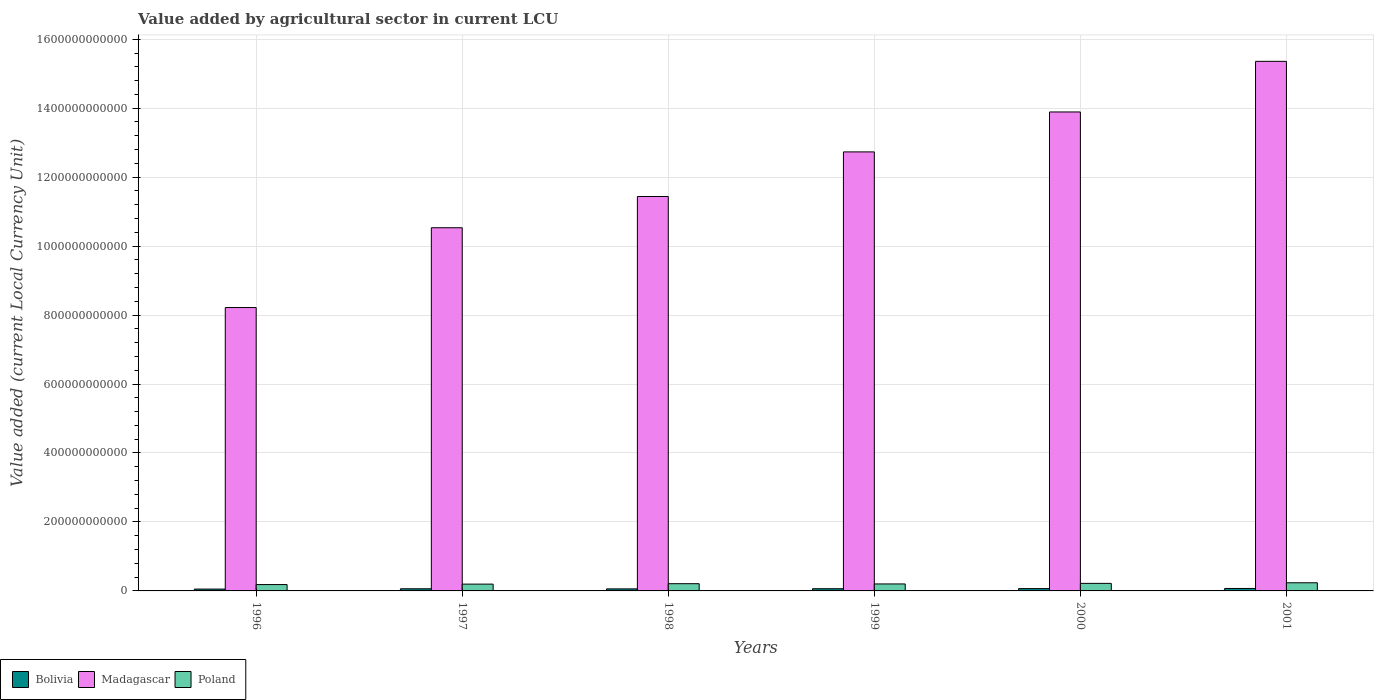Are the number of bars on each tick of the X-axis equal?
Provide a short and direct response. Yes. How many bars are there on the 4th tick from the left?
Ensure brevity in your answer.  3. How many bars are there on the 6th tick from the right?
Your response must be concise. 3. What is the value added by agricultural sector in Madagascar in 1998?
Your answer should be compact. 1.14e+12. Across all years, what is the maximum value added by agricultural sector in Poland?
Give a very brief answer. 2.36e+1. Across all years, what is the minimum value added by agricultural sector in Bolivia?
Your answer should be very brief. 5.32e+09. What is the total value added by agricultural sector in Madagascar in the graph?
Give a very brief answer. 7.22e+12. What is the difference between the value added by agricultural sector in Poland in 2000 and that in 2001?
Keep it short and to the point. -1.78e+09. What is the difference between the value added by agricultural sector in Poland in 2000 and the value added by agricultural sector in Bolivia in 1998?
Your response must be concise. 1.59e+1. What is the average value added by agricultural sector in Poland per year?
Give a very brief answer. 2.08e+1. In the year 1997, what is the difference between the value added by agricultural sector in Bolivia and value added by agricultural sector in Poland?
Your response must be concise. -1.35e+1. What is the ratio of the value added by agricultural sector in Bolivia in 1996 to that in 2001?
Give a very brief answer. 0.75. Is the value added by agricultural sector in Poland in 1998 less than that in 1999?
Your answer should be very brief. No. Is the difference between the value added by agricultural sector in Bolivia in 1998 and 1999 greater than the difference between the value added by agricultural sector in Poland in 1998 and 1999?
Your answer should be very brief. No. What is the difference between the highest and the second highest value added by agricultural sector in Bolivia?
Provide a succinct answer. 3.97e+08. What is the difference between the highest and the lowest value added by agricultural sector in Bolivia?
Offer a very short reply. 1.81e+09. Is the sum of the value added by agricultural sector in Poland in 1997 and 1999 greater than the maximum value added by agricultural sector in Bolivia across all years?
Your answer should be compact. Yes. What does the 3rd bar from the left in 1997 represents?
Provide a short and direct response. Poland. Are all the bars in the graph horizontal?
Make the answer very short. No. How many years are there in the graph?
Provide a succinct answer. 6. What is the difference between two consecutive major ticks on the Y-axis?
Keep it short and to the point. 2.00e+11. Are the values on the major ticks of Y-axis written in scientific E-notation?
Your answer should be compact. No. Where does the legend appear in the graph?
Provide a short and direct response. Bottom left. What is the title of the graph?
Offer a very short reply. Value added by agricultural sector in current LCU. Does "Trinidad and Tobago" appear as one of the legend labels in the graph?
Your response must be concise. No. What is the label or title of the X-axis?
Offer a terse response. Years. What is the label or title of the Y-axis?
Your response must be concise. Value added (current Local Currency Unit). What is the Value added (current Local Currency Unit) of Bolivia in 1996?
Ensure brevity in your answer.  5.32e+09. What is the Value added (current Local Currency Unit) in Madagascar in 1996?
Offer a terse response. 8.22e+11. What is the Value added (current Local Currency Unit) in Poland in 1996?
Your answer should be compact. 1.84e+1. What is the Value added (current Local Currency Unit) in Bolivia in 1997?
Offer a terse response. 6.21e+09. What is the Value added (current Local Currency Unit) of Madagascar in 1997?
Provide a short and direct response. 1.05e+12. What is the Value added (current Local Currency Unit) in Poland in 1997?
Provide a succinct answer. 1.97e+1. What is the Value added (current Local Currency Unit) in Bolivia in 1998?
Offer a terse response. 5.91e+09. What is the Value added (current Local Currency Unit) of Madagascar in 1998?
Your response must be concise. 1.14e+12. What is the Value added (current Local Currency Unit) of Poland in 1998?
Provide a succinct answer. 2.09e+1. What is the Value added (current Local Currency Unit) of Bolivia in 1999?
Provide a succinct answer. 6.38e+09. What is the Value added (current Local Currency Unit) of Madagascar in 1999?
Keep it short and to the point. 1.27e+12. What is the Value added (current Local Currency Unit) of Poland in 1999?
Offer a very short reply. 2.02e+1. What is the Value added (current Local Currency Unit) of Bolivia in 2000?
Offer a very short reply. 6.73e+09. What is the Value added (current Local Currency Unit) in Madagascar in 2000?
Provide a succinct answer. 1.39e+12. What is the Value added (current Local Currency Unit) of Poland in 2000?
Offer a very short reply. 2.18e+1. What is the Value added (current Local Currency Unit) of Bolivia in 2001?
Offer a terse response. 7.13e+09. What is the Value added (current Local Currency Unit) of Madagascar in 2001?
Provide a short and direct response. 1.54e+12. What is the Value added (current Local Currency Unit) in Poland in 2001?
Ensure brevity in your answer.  2.36e+1. Across all years, what is the maximum Value added (current Local Currency Unit) in Bolivia?
Offer a terse response. 7.13e+09. Across all years, what is the maximum Value added (current Local Currency Unit) in Madagascar?
Make the answer very short. 1.54e+12. Across all years, what is the maximum Value added (current Local Currency Unit) in Poland?
Your answer should be compact. 2.36e+1. Across all years, what is the minimum Value added (current Local Currency Unit) in Bolivia?
Ensure brevity in your answer.  5.32e+09. Across all years, what is the minimum Value added (current Local Currency Unit) of Madagascar?
Your answer should be compact. 8.22e+11. Across all years, what is the minimum Value added (current Local Currency Unit) of Poland?
Your answer should be compact. 1.84e+1. What is the total Value added (current Local Currency Unit) of Bolivia in the graph?
Keep it short and to the point. 3.77e+1. What is the total Value added (current Local Currency Unit) of Madagascar in the graph?
Your answer should be very brief. 7.22e+12. What is the total Value added (current Local Currency Unit) of Poland in the graph?
Your answer should be very brief. 1.25e+11. What is the difference between the Value added (current Local Currency Unit) in Bolivia in 1996 and that in 1997?
Provide a short and direct response. -8.88e+08. What is the difference between the Value added (current Local Currency Unit) of Madagascar in 1996 and that in 1997?
Offer a very short reply. -2.31e+11. What is the difference between the Value added (current Local Currency Unit) of Poland in 1996 and that in 1997?
Your answer should be very brief. -1.31e+09. What is the difference between the Value added (current Local Currency Unit) of Bolivia in 1996 and that in 1998?
Offer a very short reply. -5.87e+08. What is the difference between the Value added (current Local Currency Unit) of Madagascar in 1996 and that in 1998?
Offer a terse response. -3.22e+11. What is the difference between the Value added (current Local Currency Unit) in Poland in 1996 and that in 1998?
Offer a very short reply. -2.53e+09. What is the difference between the Value added (current Local Currency Unit) in Bolivia in 1996 and that in 1999?
Your answer should be very brief. -1.06e+09. What is the difference between the Value added (current Local Currency Unit) of Madagascar in 1996 and that in 1999?
Keep it short and to the point. -4.51e+11. What is the difference between the Value added (current Local Currency Unit) in Poland in 1996 and that in 1999?
Provide a short and direct response. -1.80e+09. What is the difference between the Value added (current Local Currency Unit) in Bolivia in 1996 and that in 2000?
Your answer should be very brief. -1.41e+09. What is the difference between the Value added (current Local Currency Unit) of Madagascar in 1996 and that in 2000?
Your response must be concise. -5.67e+11. What is the difference between the Value added (current Local Currency Unit) of Poland in 1996 and that in 2000?
Ensure brevity in your answer.  -3.42e+09. What is the difference between the Value added (current Local Currency Unit) of Bolivia in 1996 and that in 2001?
Offer a terse response. -1.81e+09. What is the difference between the Value added (current Local Currency Unit) in Madagascar in 1996 and that in 2001?
Provide a short and direct response. -7.14e+11. What is the difference between the Value added (current Local Currency Unit) in Poland in 1996 and that in 2001?
Provide a succinct answer. -5.20e+09. What is the difference between the Value added (current Local Currency Unit) in Bolivia in 1997 and that in 1998?
Ensure brevity in your answer.  3.01e+08. What is the difference between the Value added (current Local Currency Unit) in Madagascar in 1997 and that in 1998?
Your answer should be compact. -9.06e+1. What is the difference between the Value added (current Local Currency Unit) of Poland in 1997 and that in 1998?
Give a very brief answer. -1.22e+09. What is the difference between the Value added (current Local Currency Unit) in Bolivia in 1997 and that in 1999?
Keep it short and to the point. -1.72e+08. What is the difference between the Value added (current Local Currency Unit) in Madagascar in 1997 and that in 1999?
Make the answer very short. -2.20e+11. What is the difference between the Value added (current Local Currency Unit) in Poland in 1997 and that in 1999?
Your answer should be very brief. -4.92e+08. What is the difference between the Value added (current Local Currency Unit) of Bolivia in 1997 and that in 2000?
Your answer should be very brief. -5.20e+08. What is the difference between the Value added (current Local Currency Unit) in Madagascar in 1997 and that in 2000?
Make the answer very short. -3.36e+11. What is the difference between the Value added (current Local Currency Unit) in Poland in 1997 and that in 2000?
Keep it short and to the point. -2.11e+09. What is the difference between the Value added (current Local Currency Unit) in Bolivia in 1997 and that in 2001?
Ensure brevity in your answer.  -9.18e+08. What is the difference between the Value added (current Local Currency Unit) of Madagascar in 1997 and that in 2001?
Offer a very short reply. -4.83e+11. What is the difference between the Value added (current Local Currency Unit) of Poland in 1997 and that in 2001?
Offer a very short reply. -3.89e+09. What is the difference between the Value added (current Local Currency Unit) in Bolivia in 1998 and that in 1999?
Offer a very short reply. -4.73e+08. What is the difference between the Value added (current Local Currency Unit) in Madagascar in 1998 and that in 1999?
Ensure brevity in your answer.  -1.29e+11. What is the difference between the Value added (current Local Currency Unit) in Poland in 1998 and that in 1999?
Give a very brief answer. 7.26e+08. What is the difference between the Value added (current Local Currency Unit) in Bolivia in 1998 and that in 2000?
Provide a succinct answer. -8.21e+08. What is the difference between the Value added (current Local Currency Unit) of Madagascar in 1998 and that in 2000?
Your response must be concise. -2.45e+11. What is the difference between the Value added (current Local Currency Unit) of Poland in 1998 and that in 2000?
Your response must be concise. -8.96e+08. What is the difference between the Value added (current Local Currency Unit) in Bolivia in 1998 and that in 2001?
Ensure brevity in your answer.  -1.22e+09. What is the difference between the Value added (current Local Currency Unit) in Madagascar in 1998 and that in 2001?
Offer a very short reply. -3.92e+11. What is the difference between the Value added (current Local Currency Unit) of Poland in 1998 and that in 2001?
Ensure brevity in your answer.  -2.68e+09. What is the difference between the Value added (current Local Currency Unit) of Bolivia in 1999 and that in 2000?
Offer a very short reply. -3.48e+08. What is the difference between the Value added (current Local Currency Unit) in Madagascar in 1999 and that in 2000?
Offer a terse response. -1.16e+11. What is the difference between the Value added (current Local Currency Unit) of Poland in 1999 and that in 2000?
Provide a succinct answer. -1.62e+09. What is the difference between the Value added (current Local Currency Unit) in Bolivia in 1999 and that in 2001?
Your response must be concise. -7.46e+08. What is the difference between the Value added (current Local Currency Unit) of Madagascar in 1999 and that in 2001?
Your answer should be compact. -2.63e+11. What is the difference between the Value added (current Local Currency Unit) of Poland in 1999 and that in 2001?
Your response must be concise. -3.40e+09. What is the difference between the Value added (current Local Currency Unit) of Bolivia in 2000 and that in 2001?
Offer a very short reply. -3.97e+08. What is the difference between the Value added (current Local Currency Unit) of Madagascar in 2000 and that in 2001?
Ensure brevity in your answer.  -1.47e+11. What is the difference between the Value added (current Local Currency Unit) in Poland in 2000 and that in 2001?
Offer a terse response. -1.78e+09. What is the difference between the Value added (current Local Currency Unit) in Bolivia in 1996 and the Value added (current Local Currency Unit) in Madagascar in 1997?
Ensure brevity in your answer.  -1.05e+12. What is the difference between the Value added (current Local Currency Unit) in Bolivia in 1996 and the Value added (current Local Currency Unit) in Poland in 1997?
Provide a short and direct response. -1.44e+1. What is the difference between the Value added (current Local Currency Unit) in Madagascar in 1996 and the Value added (current Local Currency Unit) in Poland in 1997?
Your answer should be very brief. 8.02e+11. What is the difference between the Value added (current Local Currency Unit) in Bolivia in 1996 and the Value added (current Local Currency Unit) in Madagascar in 1998?
Provide a succinct answer. -1.14e+12. What is the difference between the Value added (current Local Currency Unit) in Bolivia in 1996 and the Value added (current Local Currency Unit) in Poland in 1998?
Ensure brevity in your answer.  -1.56e+1. What is the difference between the Value added (current Local Currency Unit) in Madagascar in 1996 and the Value added (current Local Currency Unit) in Poland in 1998?
Offer a terse response. 8.01e+11. What is the difference between the Value added (current Local Currency Unit) in Bolivia in 1996 and the Value added (current Local Currency Unit) in Madagascar in 1999?
Your answer should be very brief. -1.27e+12. What is the difference between the Value added (current Local Currency Unit) in Bolivia in 1996 and the Value added (current Local Currency Unit) in Poland in 1999?
Give a very brief answer. -1.49e+1. What is the difference between the Value added (current Local Currency Unit) in Madagascar in 1996 and the Value added (current Local Currency Unit) in Poland in 1999?
Ensure brevity in your answer.  8.02e+11. What is the difference between the Value added (current Local Currency Unit) in Bolivia in 1996 and the Value added (current Local Currency Unit) in Madagascar in 2000?
Offer a very short reply. -1.38e+12. What is the difference between the Value added (current Local Currency Unit) in Bolivia in 1996 and the Value added (current Local Currency Unit) in Poland in 2000?
Your response must be concise. -1.65e+1. What is the difference between the Value added (current Local Currency Unit) of Madagascar in 1996 and the Value added (current Local Currency Unit) of Poland in 2000?
Offer a very short reply. 8.00e+11. What is the difference between the Value added (current Local Currency Unit) of Bolivia in 1996 and the Value added (current Local Currency Unit) of Madagascar in 2001?
Your answer should be very brief. -1.53e+12. What is the difference between the Value added (current Local Currency Unit) of Bolivia in 1996 and the Value added (current Local Currency Unit) of Poland in 2001?
Provide a succinct answer. -1.83e+1. What is the difference between the Value added (current Local Currency Unit) of Madagascar in 1996 and the Value added (current Local Currency Unit) of Poland in 2001?
Your response must be concise. 7.98e+11. What is the difference between the Value added (current Local Currency Unit) in Bolivia in 1997 and the Value added (current Local Currency Unit) in Madagascar in 1998?
Ensure brevity in your answer.  -1.14e+12. What is the difference between the Value added (current Local Currency Unit) in Bolivia in 1997 and the Value added (current Local Currency Unit) in Poland in 1998?
Your answer should be very brief. -1.47e+1. What is the difference between the Value added (current Local Currency Unit) of Madagascar in 1997 and the Value added (current Local Currency Unit) of Poland in 1998?
Offer a terse response. 1.03e+12. What is the difference between the Value added (current Local Currency Unit) in Bolivia in 1997 and the Value added (current Local Currency Unit) in Madagascar in 1999?
Offer a very short reply. -1.27e+12. What is the difference between the Value added (current Local Currency Unit) of Bolivia in 1997 and the Value added (current Local Currency Unit) of Poland in 1999?
Give a very brief answer. -1.40e+1. What is the difference between the Value added (current Local Currency Unit) in Madagascar in 1997 and the Value added (current Local Currency Unit) in Poland in 1999?
Your response must be concise. 1.03e+12. What is the difference between the Value added (current Local Currency Unit) in Bolivia in 1997 and the Value added (current Local Currency Unit) in Madagascar in 2000?
Your response must be concise. -1.38e+12. What is the difference between the Value added (current Local Currency Unit) of Bolivia in 1997 and the Value added (current Local Currency Unit) of Poland in 2000?
Your response must be concise. -1.56e+1. What is the difference between the Value added (current Local Currency Unit) in Madagascar in 1997 and the Value added (current Local Currency Unit) in Poland in 2000?
Ensure brevity in your answer.  1.03e+12. What is the difference between the Value added (current Local Currency Unit) of Bolivia in 1997 and the Value added (current Local Currency Unit) of Madagascar in 2001?
Provide a short and direct response. -1.53e+12. What is the difference between the Value added (current Local Currency Unit) in Bolivia in 1997 and the Value added (current Local Currency Unit) in Poland in 2001?
Keep it short and to the point. -1.74e+1. What is the difference between the Value added (current Local Currency Unit) of Madagascar in 1997 and the Value added (current Local Currency Unit) of Poland in 2001?
Your answer should be very brief. 1.03e+12. What is the difference between the Value added (current Local Currency Unit) of Bolivia in 1998 and the Value added (current Local Currency Unit) of Madagascar in 1999?
Provide a succinct answer. -1.27e+12. What is the difference between the Value added (current Local Currency Unit) of Bolivia in 1998 and the Value added (current Local Currency Unit) of Poland in 1999?
Your answer should be very brief. -1.43e+1. What is the difference between the Value added (current Local Currency Unit) in Madagascar in 1998 and the Value added (current Local Currency Unit) in Poland in 1999?
Offer a very short reply. 1.12e+12. What is the difference between the Value added (current Local Currency Unit) of Bolivia in 1998 and the Value added (current Local Currency Unit) of Madagascar in 2000?
Provide a succinct answer. -1.38e+12. What is the difference between the Value added (current Local Currency Unit) of Bolivia in 1998 and the Value added (current Local Currency Unit) of Poland in 2000?
Offer a very short reply. -1.59e+1. What is the difference between the Value added (current Local Currency Unit) of Madagascar in 1998 and the Value added (current Local Currency Unit) of Poland in 2000?
Your answer should be very brief. 1.12e+12. What is the difference between the Value added (current Local Currency Unit) of Bolivia in 1998 and the Value added (current Local Currency Unit) of Madagascar in 2001?
Offer a very short reply. -1.53e+12. What is the difference between the Value added (current Local Currency Unit) of Bolivia in 1998 and the Value added (current Local Currency Unit) of Poland in 2001?
Ensure brevity in your answer.  -1.77e+1. What is the difference between the Value added (current Local Currency Unit) in Madagascar in 1998 and the Value added (current Local Currency Unit) in Poland in 2001?
Keep it short and to the point. 1.12e+12. What is the difference between the Value added (current Local Currency Unit) in Bolivia in 1999 and the Value added (current Local Currency Unit) in Madagascar in 2000?
Make the answer very short. -1.38e+12. What is the difference between the Value added (current Local Currency Unit) in Bolivia in 1999 and the Value added (current Local Currency Unit) in Poland in 2000?
Keep it short and to the point. -1.55e+1. What is the difference between the Value added (current Local Currency Unit) of Madagascar in 1999 and the Value added (current Local Currency Unit) of Poland in 2000?
Offer a terse response. 1.25e+12. What is the difference between the Value added (current Local Currency Unit) of Bolivia in 1999 and the Value added (current Local Currency Unit) of Madagascar in 2001?
Offer a terse response. -1.53e+12. What is the difference between the Value added (current Local Currency Unit) in Bolivia in 1999 and the Value added (current Local Currency Unit) in Poland in 2001?
Make the answer very short. -1.72e+1. What is the difference between the Value added (current Local Currency Unit) in Madagascar in 1999 and the Value added (current Local Currency Unit) in Poland in 2001?
Make the answer very short. 1.25e+12. What is the difference between the Value added (current Local Currency Unit) of Bolivia in 2000 and the Value added (current Local Currency Unit) of Madagascar in 2001?
Ensure brevity in your answer.  -1.53e+12. What is the difference between the Value added (current Local Currency Unit) in Bolivia in 2000 and the Value added (current Local Currency Unit) in Poland in 2001?
Offer a very short reply. -1.69e+1. What is the difference between the Value added (current Local Currency Unit) in Madagascar in 2000 and the Value added (current Local Currency Unit) in Poland in 2001?
Your answer should be compact. 1.37e+12. What is the average Value added (current Local Currency Unit) of Bolivia per year?
Provide a succinct answer. 6.28e+09. What is the average Value added (current Local Currency Unit) in Madagascar per year?
Offer a terse response. 1.20e+12. What is the average Value added (current Local Currency Unit) in Poland per year?
Offer a terse response. 2.08e+1. In the year 1996, what is the difference between the Value added (current Local Currency Unit) in Bolivia and Value added (current Local Currency Unit) in Madagascar?
Keep it short and to the point. -8.17e+11. In the year 1996, what is the difference between the Value added (current Local Currency Unit) in Bolivia and Value added (current Local Currency Unit) in Poland?
Your answer should be very brief. -1.31e+1. In the year 1996, what is the difference between the Value added (current Local Currency Unit) in Madagascar and Value added (current Local Currency Unit) in Poland?
Your answer should be very brief. 8.03e+11. In the year 1997, what is the difference between the Value added (current Local Currency Unit) of Bolivia and Value added (current Local Currency Unit) of Madagascar?
Make the answer very short. -1.05e+12. In the year 1997, what is the difference between the Value added (current Local Currency Unit) of Bolivia and Value added (current Local Currency Unit) of Poland?
Your answer should be compact. -1.35e+1. In the year 1997, what is the difference between the Value added (current Local Currency Unit) of Madagascar and Value added (current Local Currency Unit) of Poland?
Your response must be concise. 1.03e+12. In the year 1998, what is the difference between the Value added (current Local Currency Unit) of Bolivia and Value added (current Local Currency Unit) of Madagascar?
Your answer should be compact. -1.14e+12. In the year 1998, what is the difference between the Value added (current Local Currency Unit) of Bolivia and Value added (current Local Currency Unit) of Poland?
Your answer should be very brief. -1.50e+1. In the year 1998, what is the difference between the Value added (current Local Currency Unit) of Madagascar and Value added (current Local Currency Unit) of Poland?
Offer a very short reply. 1.12e+12. In the year 1999, what is the difference between the Value added (current Local Currency Unit) in Bolivia and Value added (current Local Currency Unit) in Madagascar?
Provide a short and direct response. -1.27e+12. In the year 1999, what is the difference between the Value added (current Local Currency Unit) in Bolivia and Value added (current Local Currency Unit) in Poland?
Make the answer very short. -1.38e+1. In the year 1999, what is the difference between the Value added (current Local Currency Unit) of Madagascar and Value added (current Local Currency Unit) of Poland?
Make the answer very short. 1.25e+12. In the year 2000, what is the difference between the Value added (current Local Currency Unit) of Bolivia and Value added (current Local Currency Unit) of Madagascar?
Your answer should be compact. -1.38e+12. In the year 2000, what is the difference between the Value added (current Local Currency Unit) in Bolivia and Value added (current Local Currency Unit) in Poland?
Offer a very short reply. -1.51e+1. In the year 2000, what is the difference between the Value added (current Local Currency Unit) in Madagascar and Value added (current Local Currency Unit) in Poland?
Your answer should be very brief. 1.37e+12. In the year 2001, what is the difference between the Value added (current Local Currency Unit) of Bolivia and Value added (current Local Currency Unit) of Madagascar?
Provide a short and direct response. -1.53e+12. In the year 2001, what is the difference between the Value added (current Local Currency Unit) in Bolivia and Value added (current Local Currency Unit) in Poland?
Make the answer very short. -1.65e+1. In the year 2001, what is the difference between the Value added (current Local Currency Unit) of Madagascar and Value added (current Local Currency Unit) of Poland?
Provide a short and direct response. 1.51e+12. What is the ratio of the Value added (current Local Currency Unit) of Bolivia in 1996 to that in 1997?
Provide a short and direct response. 0.86. What is the ratio of the Value added (current Local Currency Unit) in Madagascar in 1996 to that in 1997?
Make the answer very short. 0.78. What is the ratio of the Value added (current Local Currency Unit) of Poland in 1996 to that in 1997?
Your answer should be very brief. 0.93. What is the ratio of the Value added (current Local Currency Unit) in Bolivia in 1996 to that in 1998?
Ensure brevity in your answer.  0.9. What is the ratio of the Value added (current Local Currency Unit) of Madagascar in 1996 to that in 1998?
Provide a succinct answer. 0.72. What is the ratio of the Value added (current Local Currency Unit) of Poland in 1996 to that in 1998?
Your answer should be very brief. 0.88. What is the ratio of the Value added (current Local Currency Unit) in Bolivia in 1996 to that in 1999?
Provide a short and direct response. 0.83. What is the ratio of the Value added (current Local Currency Unit) of Madagascar in 1996 to that in 1999?
Keep it short and to the point. 0.65. What is the ratio of the Value added (current Local Currency Unit) in Poland in 1996 to that in 1999?
Your answer should be very brief. 0.91. What is the ratio of the Value added (current Local Currency Unit) of Bolivia in 1996 to that in 2000?
Give a very brief answer. 0.79. What is the ratio of the Value added (current Local Currency Unit) in Madagascar in 1996 to that in 2000?
Offer a very short reply. 0.59. What is the ratio of the Value added (current Local Currency Unit) of Poland in 1996 to that in 2000?
Keep it short and to the point. 0.84. What is the ratio of the Value added (current Local Currency Unit) of Bolivia in 1996 to that in 2001?
Ensure brevity in your answer.  0.75. What is the ratio of the Value added (current Local Currency Unit) in Madagascar in 1996 to that in 2001?
Provide a short and direct response. 0.54. What is the ratio of the Value added (current Local Currency Unit) of Poland in 1996 to that in 2001?
Give a very brief answer. 0.78. What is the ratio of the Value added (current Local Currency Unit) of Bolivia in 1997 to that in 1998?
Offer a terse response. 1.05. What is the ratio of the Value added (current Local Currency Unit) of Madagascar in 1997 to that in 1998?
Keep it short and to the point. 0.92. What is the ratio of the Value added (current Local Currency Unit) of Poland in 1997 to that in 1998?
Your answer should be compact. 0.94. What is the ratio of the Value added (current Local Currency Unit) in Bolivia in 1997 to that in 1999?
Keep it short and to the point. 0.97. What is the ratio of the Value added (current Local Currency Unit) of Madagascar in 1997 to that in 1999?
Ensure brevity in your answer.  0.83. What is the ratio of the Value added (current Local Currency Unit) of Poland in 1997 to that in 1999?
Your answer should be very brief. 0.98. What is the ratio of the Value added (current Local Currency Unit) in Bolivia in 1997 to that in 2000?
Your answer should be compact. 0.92. What is the ratio of the Value added (current Local Currency Unit) in Madagascar in 1997 to that in 2000?
Your answer should be compact. 0.76. What is the ratio of the Value added (current Local Currency Unit) in Poland in 1997 to that in 2000?
Provide a succinct answer. 0.9. What is the ratio of the Value added (current Local Currency Unit) in Bolivia in 1997 to that in 2001?
Your answer should be very brief. 0.87. What is the ratio of the Value added (current Local Currency Unit) in Madagascar in 1997 to that in 2001?
Keep it short and to the point. 0.69. What is the ratio of the Value added (current Local Currency Unit) in Poland in 1997 to that in 2001?
Keep it short and to the point. 0.84. What is the ratio of the Value added (current Local Currency Unit) in Bolivia in 1998 to that in 1999?
Ensure brevity in your answer.  0.93. What is the ratio of the Value added (current Local Currency Unit) in Madagascar in 1998 to that in 1999?
Provide a succinct answer. 0.9. What is the ratio of the Value added (current Local Currency Unit) of Poland in 1998 to that in 1999?
Offer a very short reply. 1.04. What is the ratio of the Value added (current Local Currency Unit) in Bolivia in 1998 to that in 2000?
Your answer should be very brief. 0.88. What is the ratio of the Value added (current Local Currency Unit) in Madagascar in 1998 to that in 2000?
Give a very brief answer. 0.82. What is the ratio of the Value added (current Local Currency Unit) of Poland in 1998 to that in 2000?
Your answer should be compact. 0.96. What is the ratio of the Value added (current Local Currency Unit) in Bolivia in 1998 to that in 2001?
Keep it short and to the point. 0.83. What is the ratio of the Value added (current Local Currency Unit) in Madagascar in 1998 to that in 2001?
Your response must be concise. 0.74. What is the ratio of the Value added (current Local Currency Unit) in Poland in 1998 to that in 2001?
Your answer should be very brief. 0.89. What is the ratio of the Value added (current Local Currency Unit) of Bolivia in 1999 to that in 2000?
Give a very brief answer. 0.95. What is the ratio of the Value added (current Local Currency Unit) of Madagascar in 1999 to that in 2000?
Give a very brief answer. 0.92. What is the ratio of the Value added (current Local Currency Unit) of Poland in 1999 to that in 2000?
Your answer should be compact. 0.93. What is the ratio of the Value added (current Local Currency Unit) in Bolivia in 1999 to that in 2001?
Your answer should be very brief. 0.9. What is the ratio of the Value added (current Local Currency Unit) in Madagascar in 1999 to that in 2001?
Your answer should be very brief. 0.83. What is the ratio of the Value added (current Local Currency Unit) in Poland in 1999 to that in 2001?
Give a very brief answer. 0.86. What is the ratio of the Value added (current Local Currency Unit) of Bolivia in 2000 to that in 2001?
Keep it short and to the point. 0.94. What is the ratio of the Value added (current Local Currency Unit) of Madagascar in 2000 to that in 2001?
Make the answer very short. 0.9. What is the ratio of the Value added (current Local Currency Unit) of Poland in 2000 to that in 2001?
Your answer should be very brief. 0.92. What is the difference between the highest and the second highest Value added (current Local Currency Unit) of Bolivia?
Provide a succinct answer. 3.97e+08. What is the difference between the highest and the second highest Value added (current Local Currency Unit) in Madagascar?
Give a very brief answer. 1.47e+11. What is the difference between the highest and the second highest Value added (current Local Currency Unit) of Poland?
Ensure brevity in your answer.  1.78e+09. What is the difference between the highest and the lowest Value added (current Local Currency Unit) of Bolivia?
Ensure brevity in your answer.  1.81e+09. What is the difference between the highest and the lowest Value added (current Local Currency Unit) in Madagascar?
Give a very brief answer. 7.14e+11. What is the difference between the highest and the lowest Value added (current Local Currency Unit) in Poland?
Make the answer very short. 5.20e+09. 